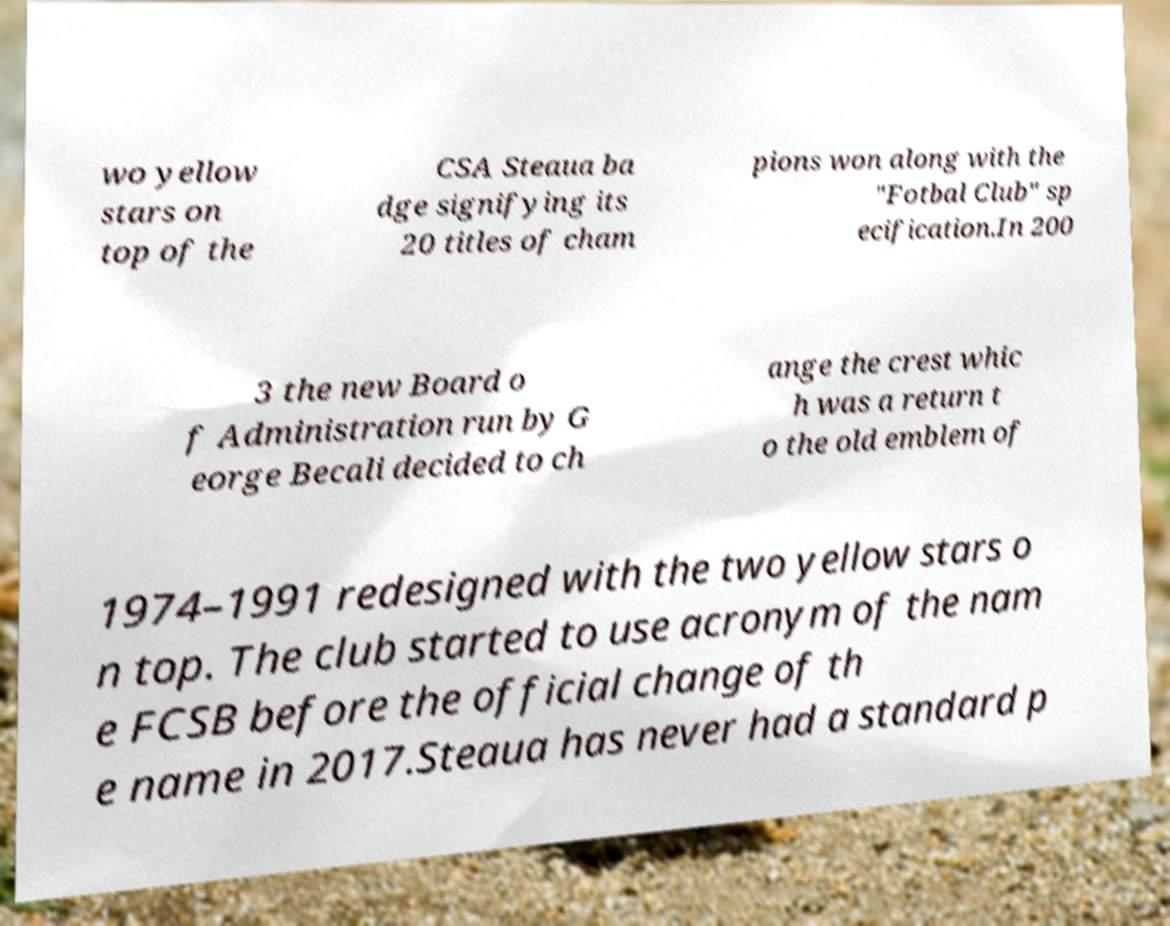Please identify and transcribe the text found in this image. wo yellow stars on top of the CSA Steaua ba dge signifying its 20 titles of cham pions won along with the "Fotbal Club" sp ecification.In 200 3 the new Board o f Administration run by G eorge Becali decided to ch ange the crest whic h was a return t o the old emblem of 1974–1991 redesigned with the two yellow stars o n top. The club started to use acronym of the nam e FCSB before the official change of th e name in 2017.Steaua has never had a standard p 